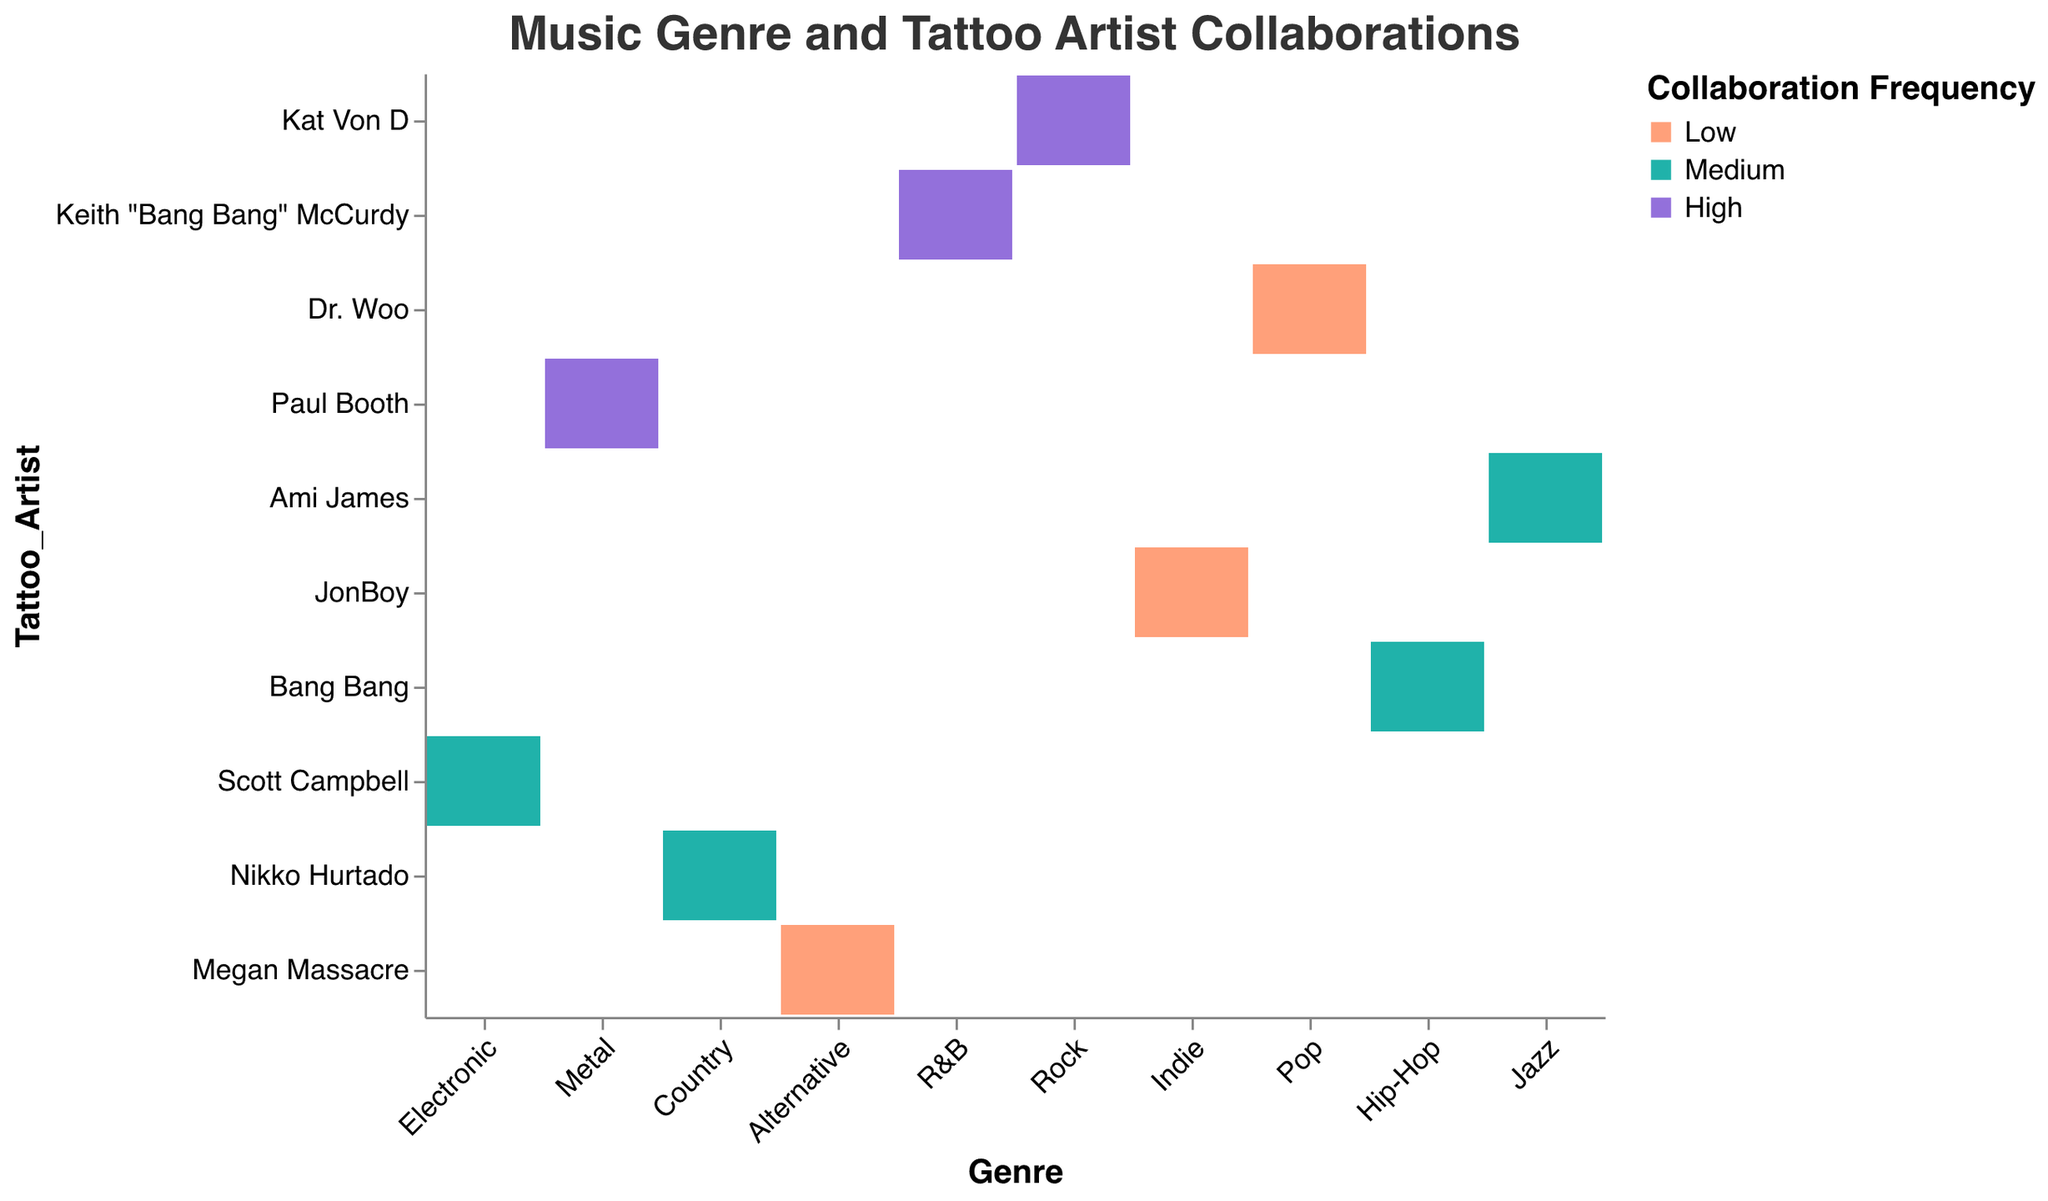What's the title of the figure? The title is usually placed at the top of the figure and provides a brief idea about the data visualization.
Answer: Music Genre and Tattoo Artist Collaborations How many genres are displayed in the figure? Count the number of distinct genres listed on the x-axis.
Answer: 10 Which tattoo artists have 'High' collaboration frequency? Look at the legend for 'High' and find corresponding cells’ colors in the figure.
Answer: Kat Von D, Keith "Bang Bang" McCurdy, Paul Booth Which genre is associated with the smallest tattoo size? Identify the smallest size in the legend and check corresponding genre cells for that size.
Answer: Pop Compare the collaboration frequency for Kat Von D and Bang Bang. Which one is higher? Locate the cells for Kat Von D and Bang Bang, and compare the colors indicating their collaboration frequency.
Answer: Kat Von D Which tattoo artist collaborated equally frequently with Country and Electronic genres? Look for a tattoo artist with the same color square for both Country and Electronic genres.
Answer: Nikko Hurtado How many genres have a 'Medium' collaboration frequency? Count the number of distinct genres with a color indicating 'Medium' collaboration frequency.
Answer: 5 Which tattoo artist has the largest tattoo size with Metal genre? Identify the cell for Metal with the largest size indicator and read the corresponding tattoo artist's name.
Answer: Paul Booth Which genre-tattoo artist pair has both 'Low' collaboration frequency and 'Small' tattoo size? Find cells with both small size and color for 'Low' collaboration frequency, then identify the genre and artist pairs.
Answer: Pop-Dr. Woo, Alternative-Megan Massacre, Indie-JonBoy Compare the collaboration frequencies between Rock and R&B. Which has a higher value, and by how much? Find the cells for Rock and R&B and compare the color for collaboration frequency. Rock has 'High' and R&B has 'High', so they are equal.
Answer: They are equal 